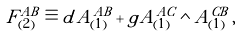<formula> <loc_0><loc_0><loc_500><loc_500>\tilde { F } ^ { A B } _ { ( 2 ) } \equiv d \tilde { A } ^ { A B } _ { ( 1 ) } + \tilde { g } \tilde { A } ^ { A C } _ { ( 1 ) } \wedge \tilde { A } ^ { C B } _ { ( 1 ) } \, ,</formula> 